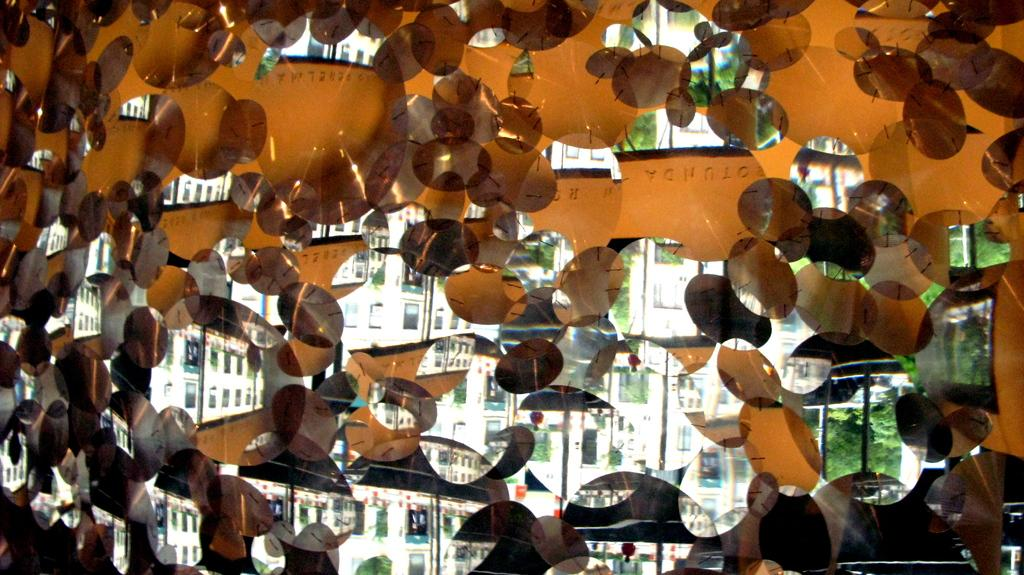What type of vegetation is on the right side of the image? There are trees on the right side of the image. What type of structures are on the left side of the image? There are buildings on the left side of the image. What type of nut can be seen growing on the trees in the image? There is no nut visible in the image, as it only features trees and buildings. How does the elbow contribute to the structure of the buildings in the image? There is no elbow present in the image, as it only features trees and buildings. 